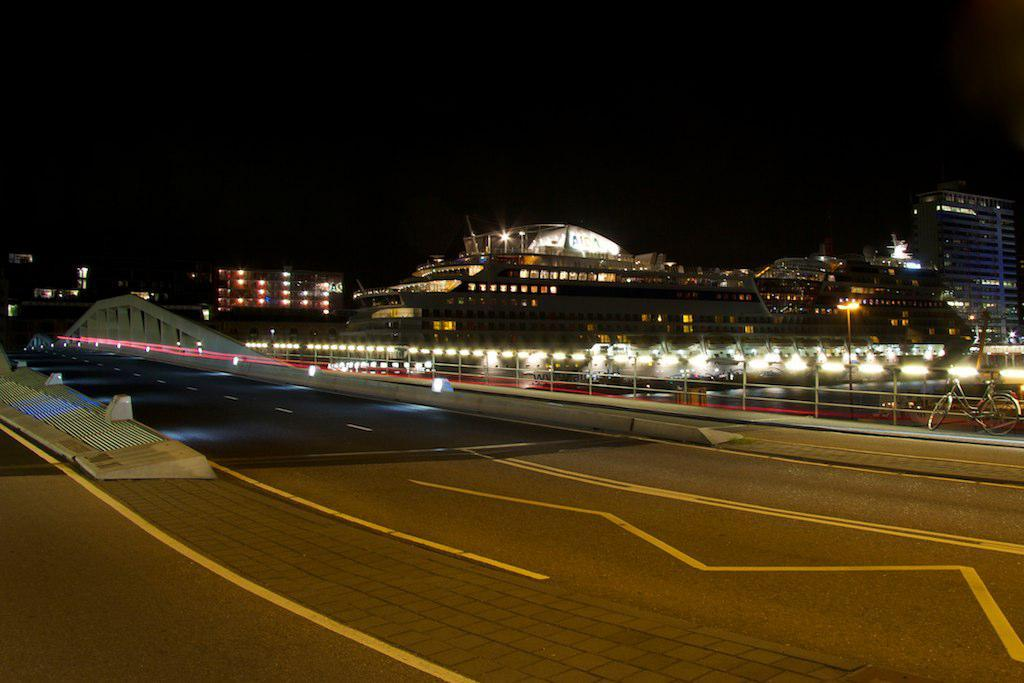What type of structures can be seen with lights in the image? There are buildings with lights in the image. Where is the bicycle located in the image? The bicycle is near a fence in the image. What type of natural elements are present in the image? There are stones in the image. What architectural features can be seen in the image? There is a wall and a railing in the image. What type of pathway is visible in the image? There is a road in the image. How would you describe the lighting conditions in the image? The background of the image is dark. What type of cheese is the farmer holding while talking to the doll in the image? There is no farmer, cheese, or doll present in the image. 